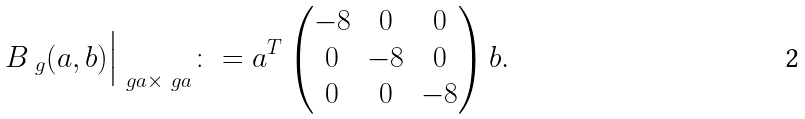Convert formula to latex. <formula><loc_0><loc_0><loc_500><loc_500>B _ { \ g } ( a , b ) { \Big | } _ { \ g a \times \ g a } \colon = a ^ { T } \begin{pmatrix} - 8 & 0 & 0 \\ 0 & - 8 & 0 \\ 0 & 0 & - 8 \end{pmatrix} b .</formula> 